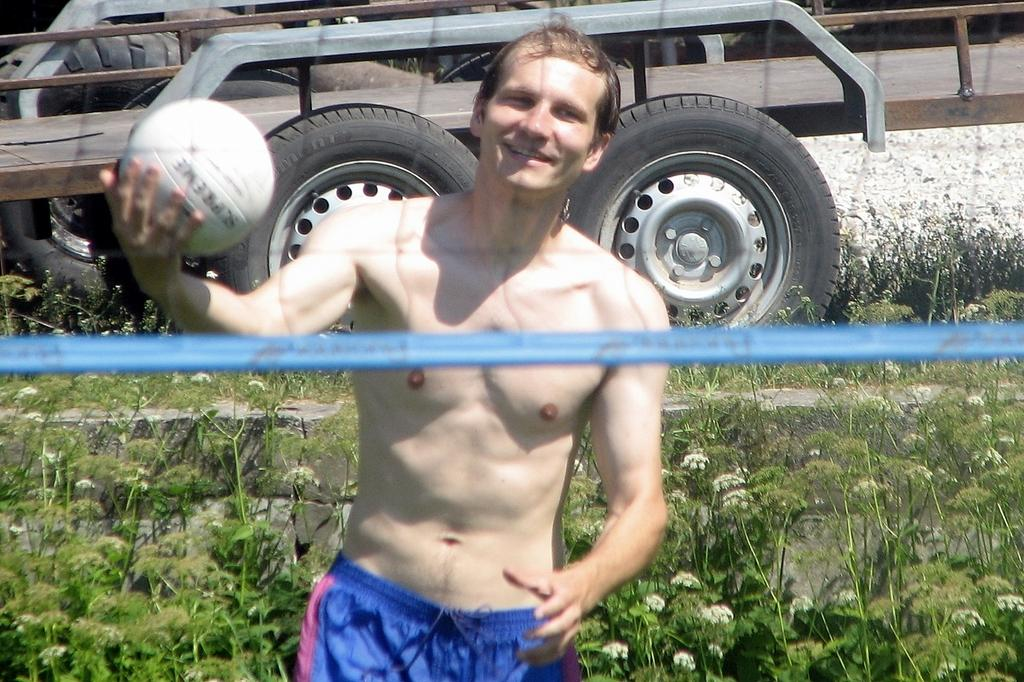Who is the main subject in the image? There is a man in the center of the image. What is the man holding in the image? The man is holding a ball. What is the man's facial expression in the image? The man is smiling. What type of vegetation can be seen in the image? There are plants visible in the image, and there is also grass. What is the color of the pipe in the image? There is a blue color pipe in the image. What can be seen in the background of the image? There is a vehicle in the background of the image. What type of drum is the man playing in the image? There is no drum present in the image; the man is holding a ball. What type of beef is being prepared in the image? There is no beef or any food preparation visible in the image. 